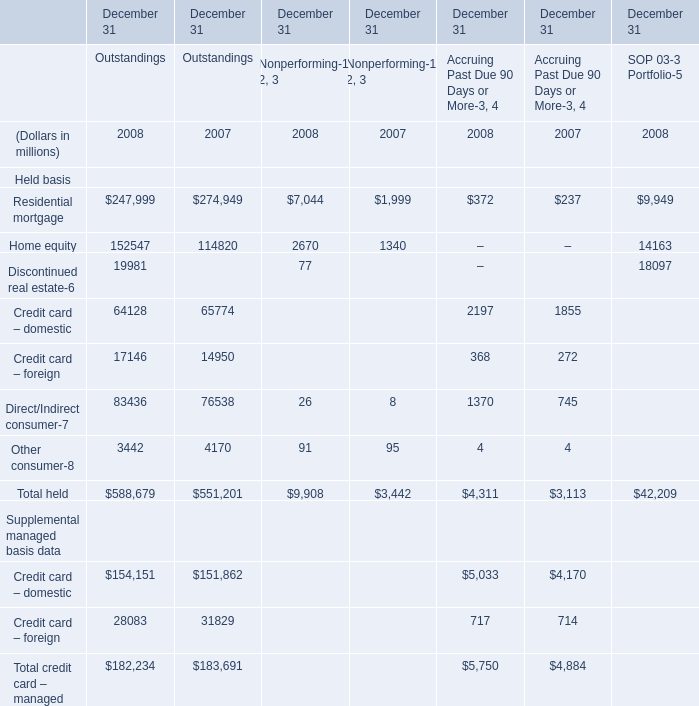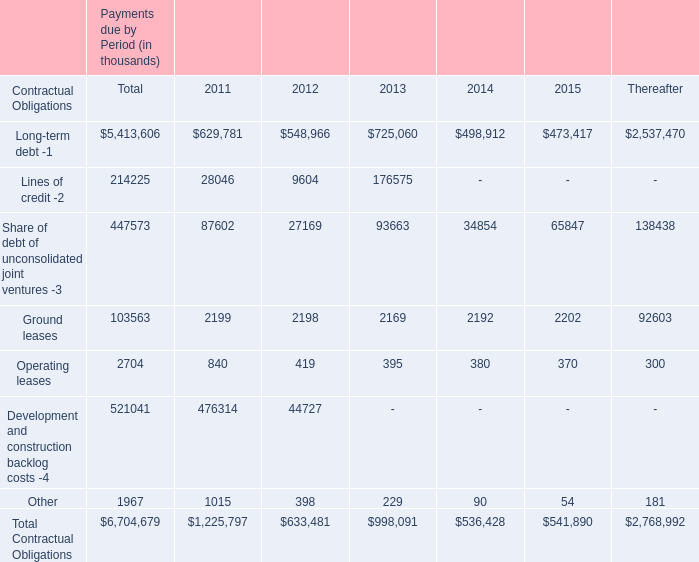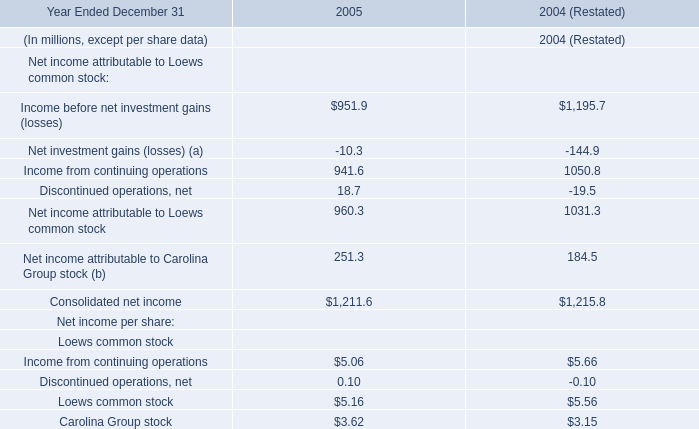what was the total revenues earned in 2016 from managementleasing and construction and development 
Computations: ((7.6 + 2.7) + (7.6 + 2.7))
Answer: 20.6. 